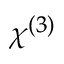<formula> <loc_0><loc_0><loc_500><loc_500>\chi ^ { ( 3 ) }</formula> 